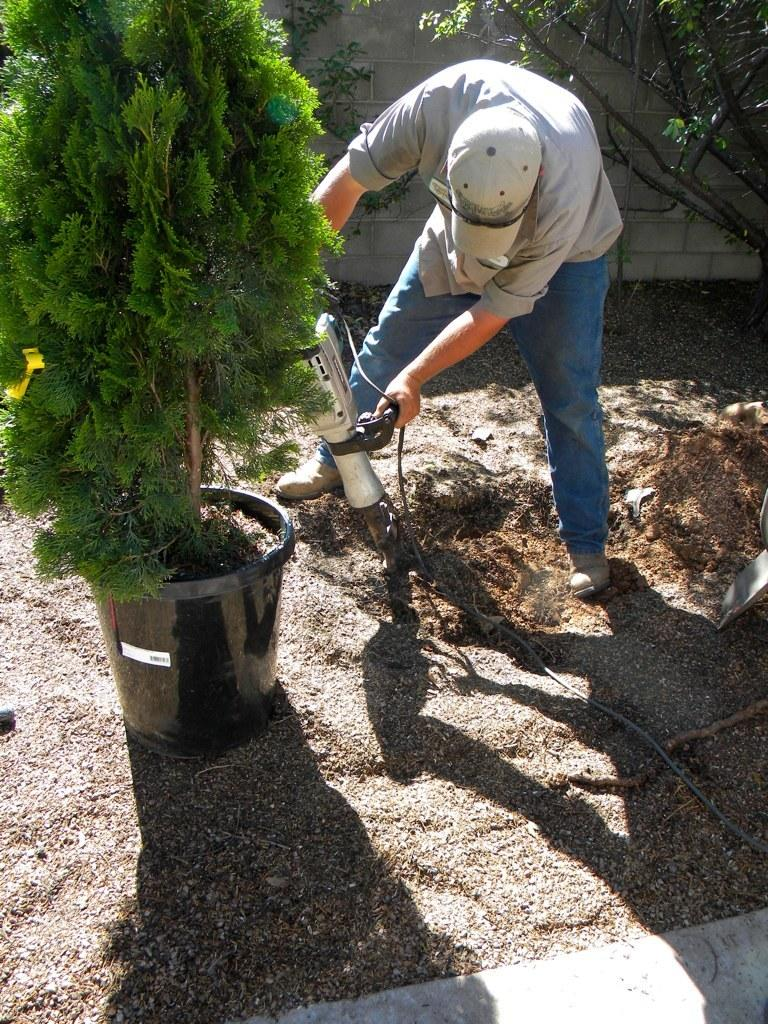What is the main subject in the center of the image? There is a plant in the center of the image. What is the person in the image doing? The person is using a drilling machine. What type of surface is visible at the bottom of the image? There is ground visible at the bottom of the image. What can be seen in the background of the image? There is a wall in the background of the image. What type of crown is the person wearing while using the drilling machine? There is no crown present in the image; the person is not wearing any headgear. 